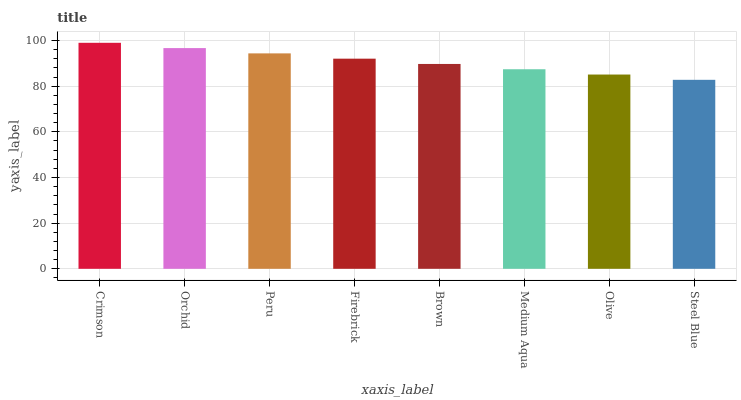Is Steel Blue the minimum?
Answer yes or no. Yes. Is Crimson the maximum?
Answer yes or no. Yes. Is Orchid the minimum?
Answer yes or no. No. Is Orchid the maximum?
Answer yes or no. No. Is Crimson greater than Orchid?
Answer yes or no. Yes. Is Orchid less than Crimson?
Answer yes or no. Yes. Is Orchid greater than Crimson?
Answer yes or no. No. Is Crimson less than Orchid?
Answer yes or no. No. Is Firebrick the high median?
Answer yes or no. Yes. Is Brown the low median?
Answer yes or no. Yes. Is Peru the high median?
Answer yes or no. No. Is Medium Aqua the low median?
Answer yes or no. No. 